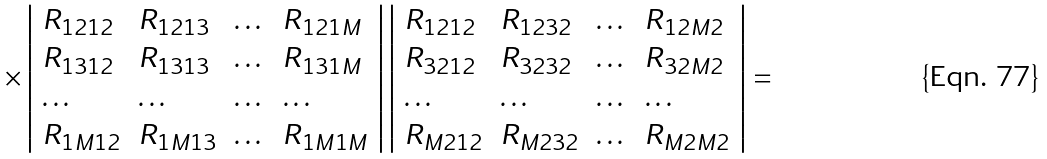Convert formula to latex. <formula><loc_0><loc_0><loc_500><loc_500>\times \left | \begin{array} { l l l l } R _ { 1 2 1 2 } & R _ { 1 2 1 3 } & \dots & R _ { 1 2 1 M } \\ R _ { 1 3 1 2 } & R _ { 1 3 1 3 } & \dots & R _ { 1 3 1 M } \\ \dots & \dots & \dots & \dots \\ R _ { 1 M 1 2 } & R _ { 1 M 1 3 } & \dots & R _ { 1 M 1 M } \end{array} \right | \left | \begin{array} { l l l l } R _ { 1 2 1 2 } & R _ { 1 2 3 2 } & \dots & R _ { 1 2 M 2 } \\ R _ { 3 2 1 2 } & R _ { 3 2 3 2 } & \dots & R _ { 3 2 M 2 } \\ \dots & \dots & \dots & \dots \\ R _ { M 2 1 2 } & R _ { M 2 3 2 } & \dots & R _ { M 2 M 2 } \end{array} \right | =</formula> 